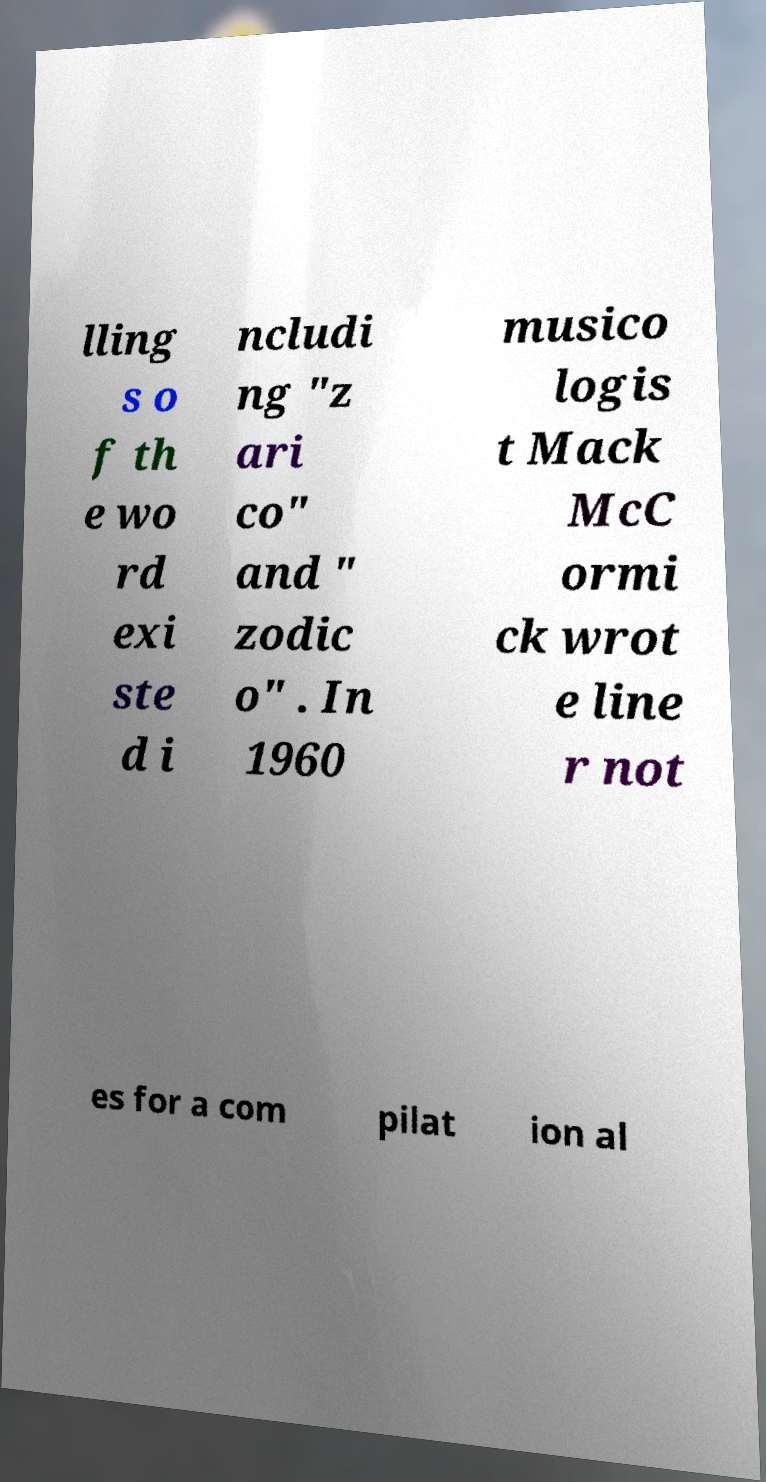Can you accurately transcribe the text from the provided image for me? lling s o f th e wo rd exi ste d i ncludi ng "z ari co" and " zodic o" . In 1960 musico logis t Mack McC ormi ck wrot e line r not es for a com pilat ion al 